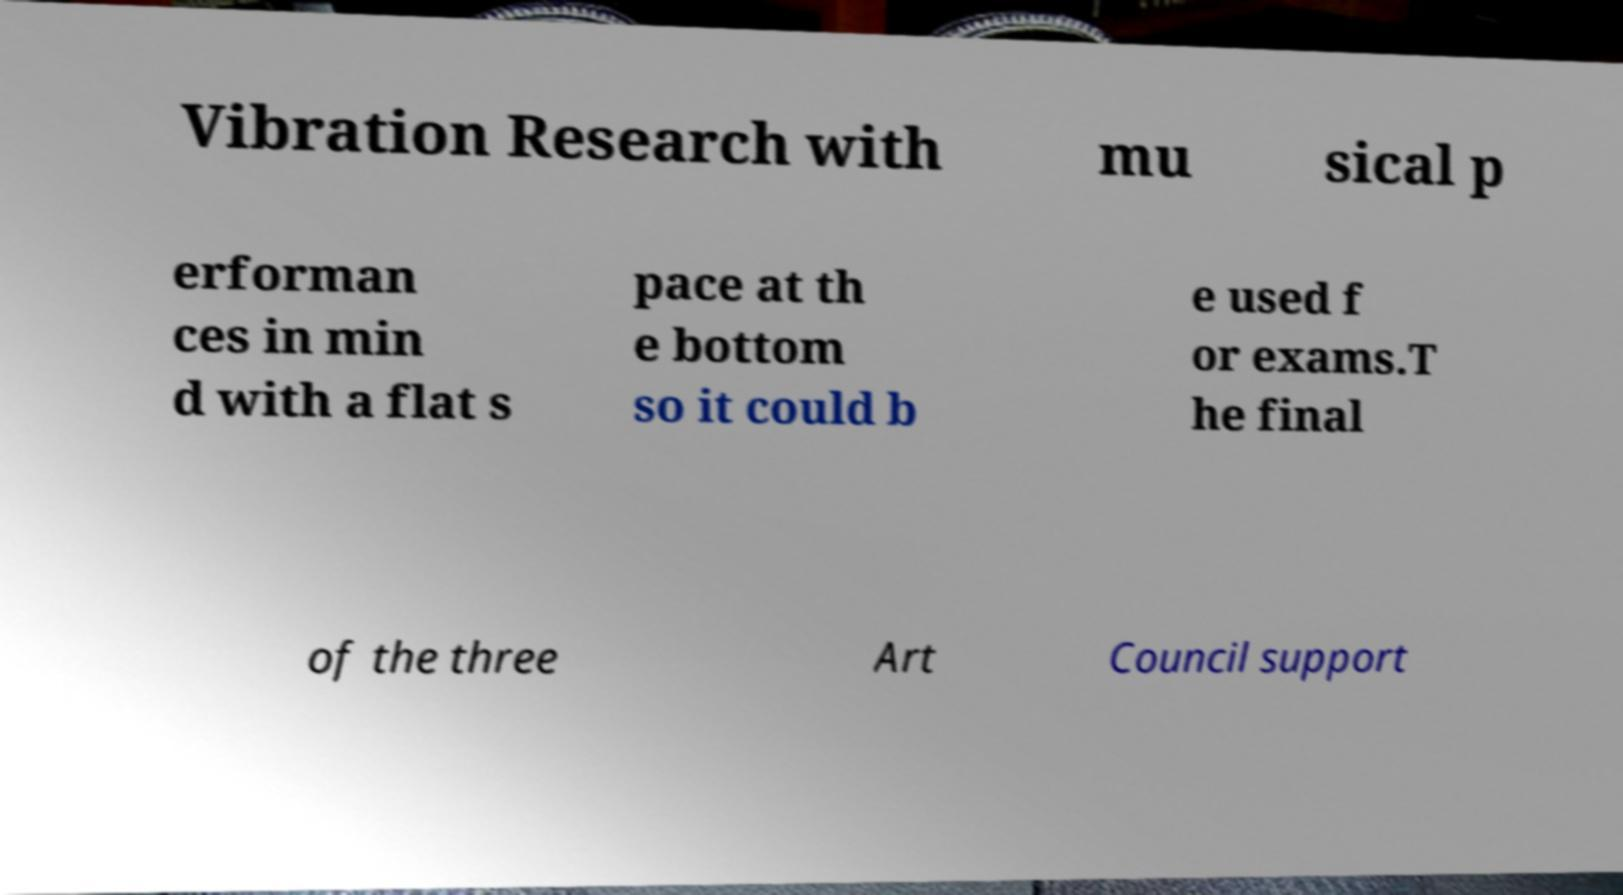Could you extract and type out the text from this image? Vibration Research with mu sical p erforman ces in min d with a flat s pace at th e bottom so it could b e used f or exams.T he final of the three Art Council support 